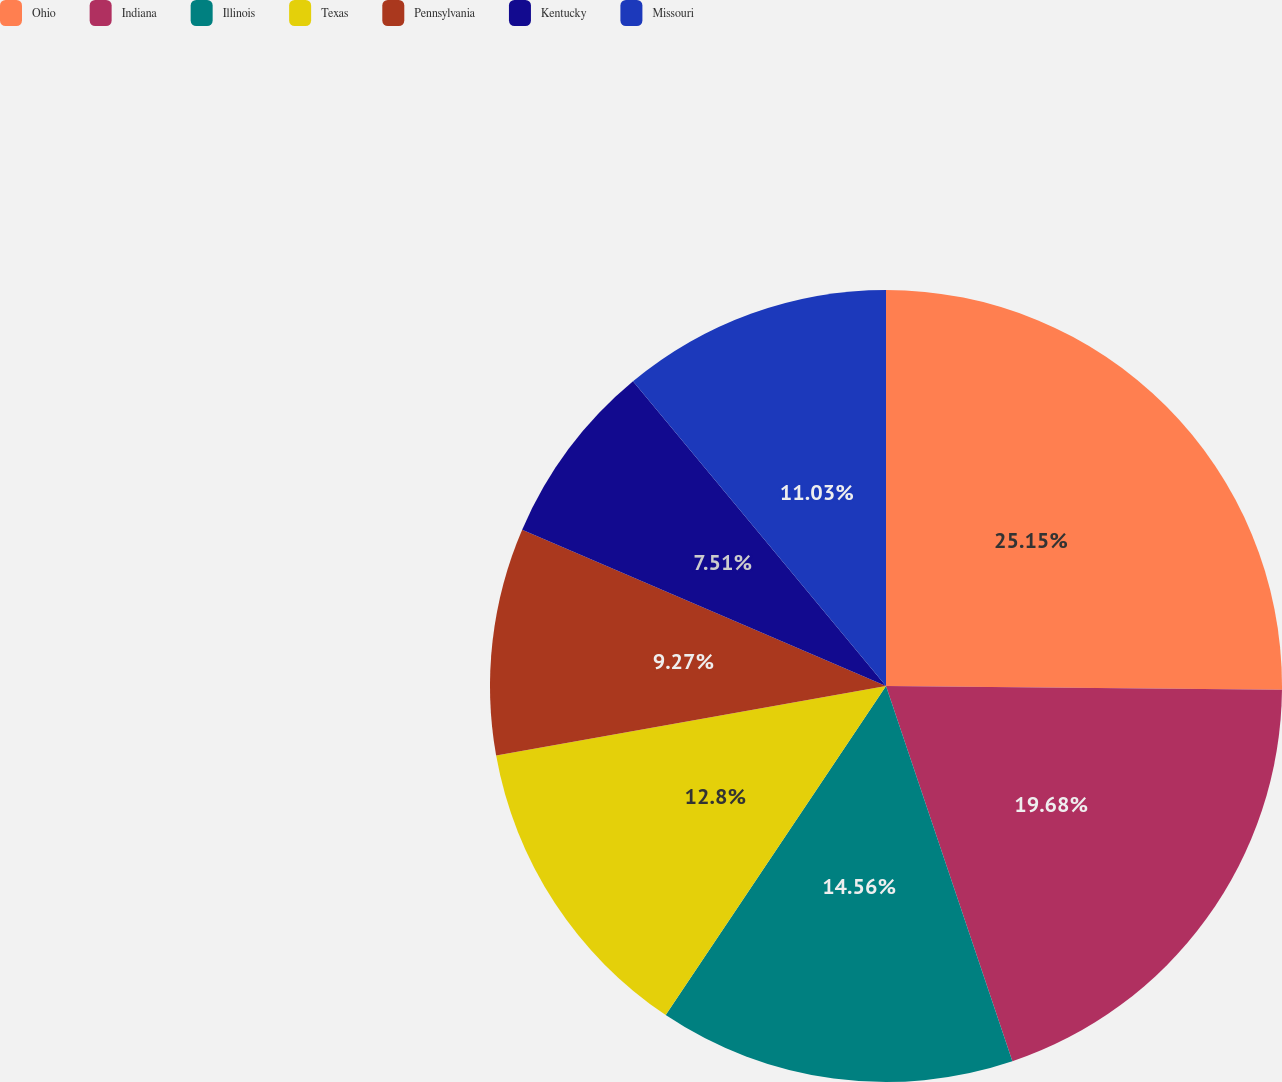Convert chart to OTSL. <chart><loc_0><loc_0><loc_500><loc_500><pie_chart><fcel>Ohio<fcel>Indiana<fcel>Illinois<fcel>Texas<fcel>Pennsylvania<fcel>Kentucky<fcel>Missouri<nl><fcel>25.15%<fcel>19.68%<fcel>14.56%<fcel>12.8%<fcel>9.27%<fcel>7.51%<fcel>11.03%<nl></chart> 